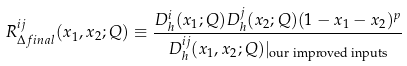Convert formula to latex. <formula><loc_0><loc_0><loc_500><loc_500>R ^ { i j } _ { \Delta f i n a l } ( x _ { 1 } , x _ { 2 } ; Q ) \equiv \frac { D _ { h } ^ { i } ( x _ { 1 } ; Q ) D _ { h } ^ { j } ( x _ { 2 } ; Q ) ( 1 - x _ { 1 } - x _ { 2 } ) ^ { p } } { D _ { h } ^ { i j } ( x _ { 1 } , x _ { 2 } ; Q ) | _ { \text {our improved inputs} } }</formula> 